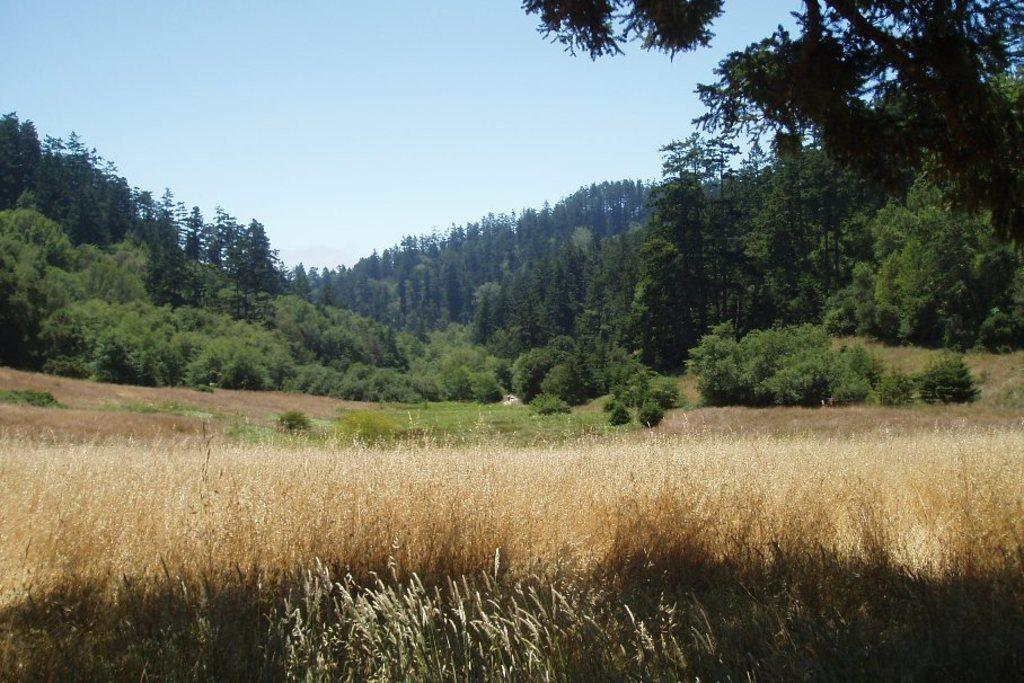What type of vegetation can be seen in the image? There is grass and plants in the image. What can be seen in the background of the image? There are trees in the background of the image. How many sisters are present in the image? There are no sisters mentioned or depicted in the image. What type of pot is used for the plants in the image? There is no pot visible in the image; the plants are not shown in a pot. 